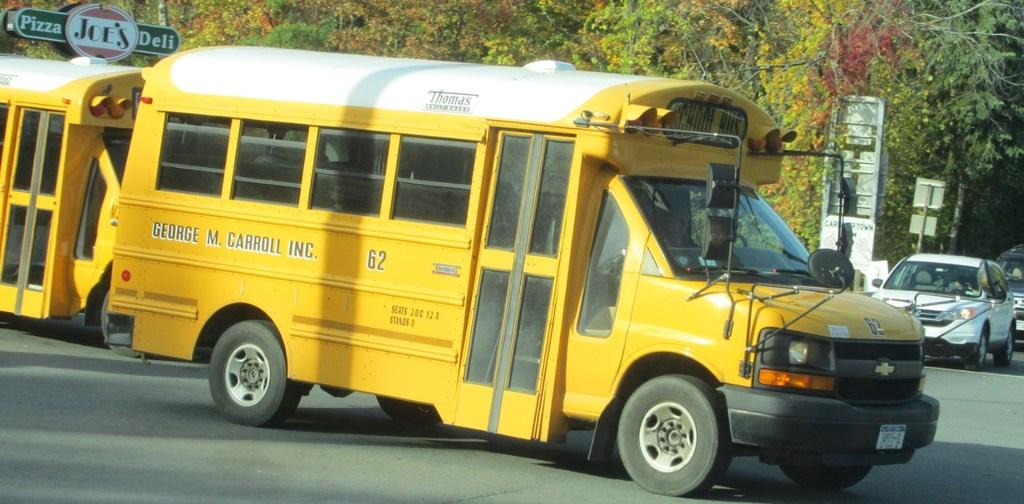What is the dominant feature in the image? There are many trees in the image. What else can be seen moving in the image? A yellow school bus and two cars are also moving in the image. Is there any signage visible in the image? Yes, there is a sign board in the image. What type of knife can be seen being used to shape the paint in the image? There is no knife, shape, or paint present in the image. 